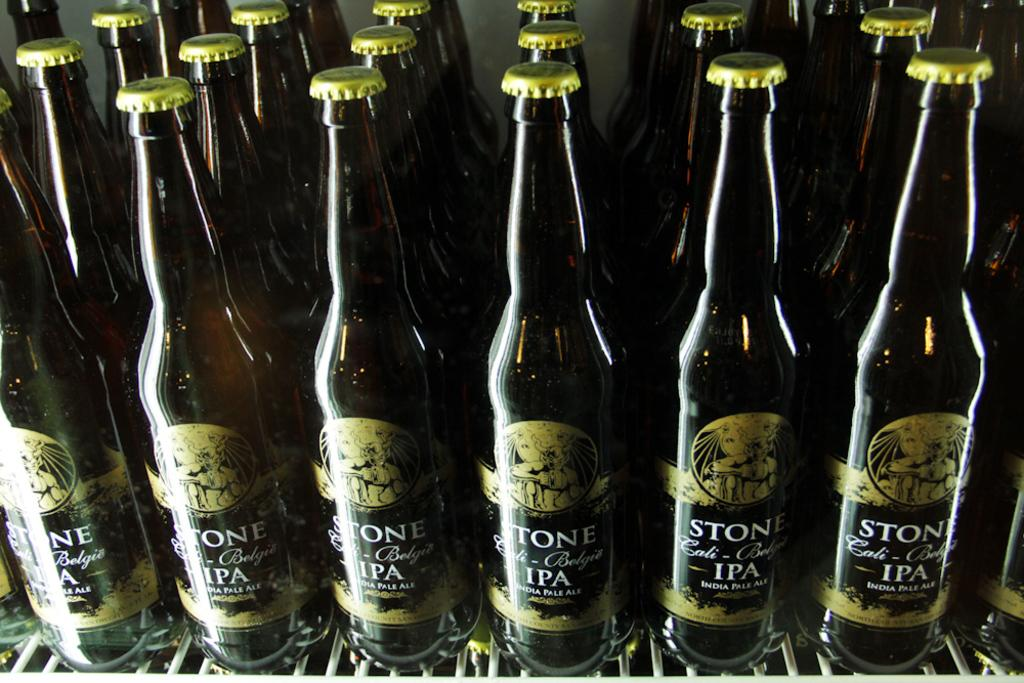<image>
Summarize the visual content of the image. A cooler shelf stocked with Stone Belgie IPA Pale Ale. 